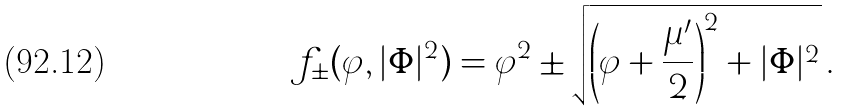<formula> <loc_0><loc_0><loc_500><loc_500>f _ { \pm } ( \varphi , | \Phi | ^ { 2 } ) = \varphi ^ { 2 } \pm \sqrt { \left ( \varphi + \frac { \mu ^ { \prime } } { 2 } \right ) ^ { 2 } + | \Phi | ^ { 2 } } \, .</formula> 